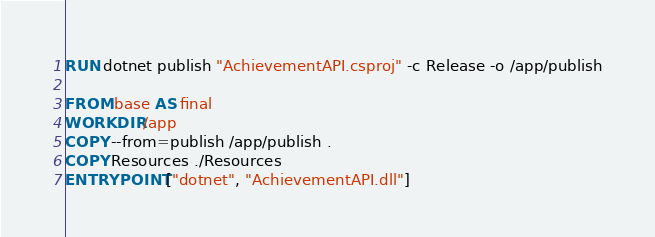Convert code to text. <code><loc_0><loc_0><loc_500><loc_500><_Dockerfile_>RUN dotnet publish "AchievementAPI.csproj" -c Release -o /app/publish

FROM base AS final
WORKDIR /app
COPY --from=publish /app/publish .
COPY Resources ./Resources
ENTRYPOINT ["dotnet", "AchievementAPI.dll"]</code> 